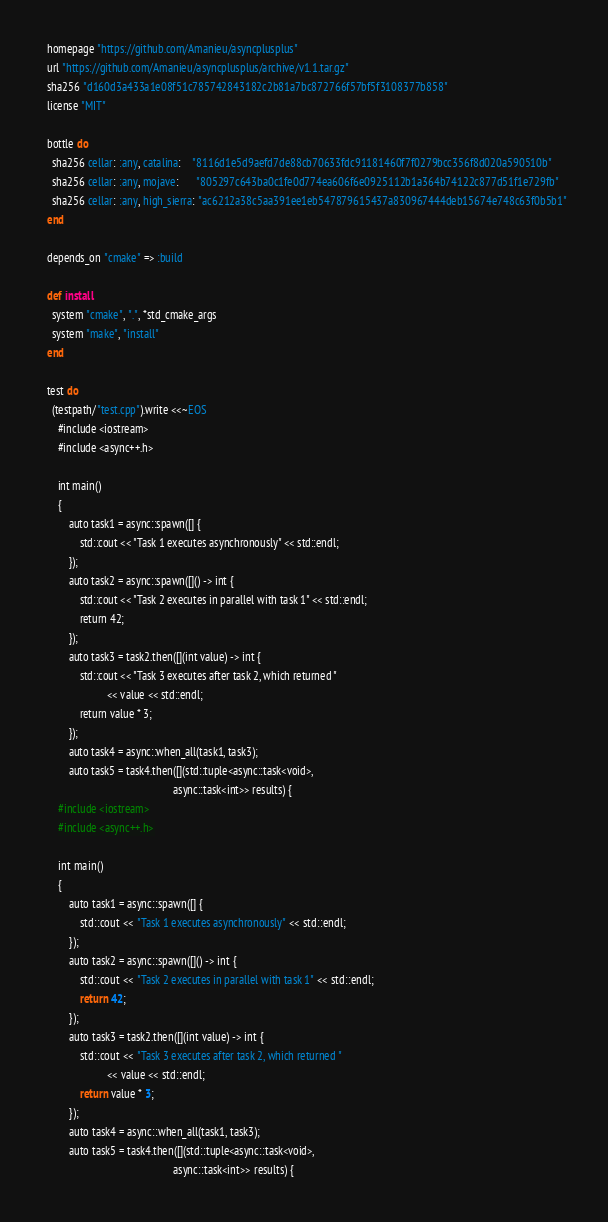Convert code to text. <code><loc_0><loc_0><loc_500><loc_500><_Ruby_>  homepage "https://github.com/Amanieu/asyncplusplus"
  url "https://github.com/Amanieu/asyncplusplus/archive/v1.1.tar.gz"
  sha256 "d160d3a433a1e08f51c785742843182c2b81a7bc872766f57bf5f3108377b858"
  license "MIT"

  bottle do
    sha256 cellar: :any, catalina:    "8116d1e5d9aefd7de88cb70633fdc91181460f7f0279bcc356f8d020a590510b"
    sha256 cellar: :any, mojave:      "805297c643ba0c1fe0d774ea606f6e0925112b1a364b74122c877d51f1e729fb"
    sha256 cellar: :any, high_sierra: "ac6212a38c5aa391ee1eb547879615437a830967444deb15674e748c63f0b5b1"
  end

  depends_on "cmake" => :build

  def install
    system "cmake", ".", *std_cmake_args
    system "make", "install"
  end

  test do
    (testpath/"test.cpp").write <<~EOS
      #include <iostream>
      #include <async++.h>

      int main()
      {
          auto task1 = async::spawn([] {
              std::cout << "Task 1 executes asynchronously" << std::endl;
          });
          auto task2 = async::spawn([]() -> int {
              std::cout << "Task 2 executes in parallel with task 1" << std::endl;
              return 42;
          });
          auto task3 = task2.then([](int value) -> int {
              std::cout << "Task 3 executes after task 2, which returned "
                        << value << std::endl;
              return value * 3;
          });
          auto task4 = async::when_all(task1, task3);
          auto task5 = task4.then([](std::tuple<async::task<void>,
                                                async::task<int>> results) {</code> 